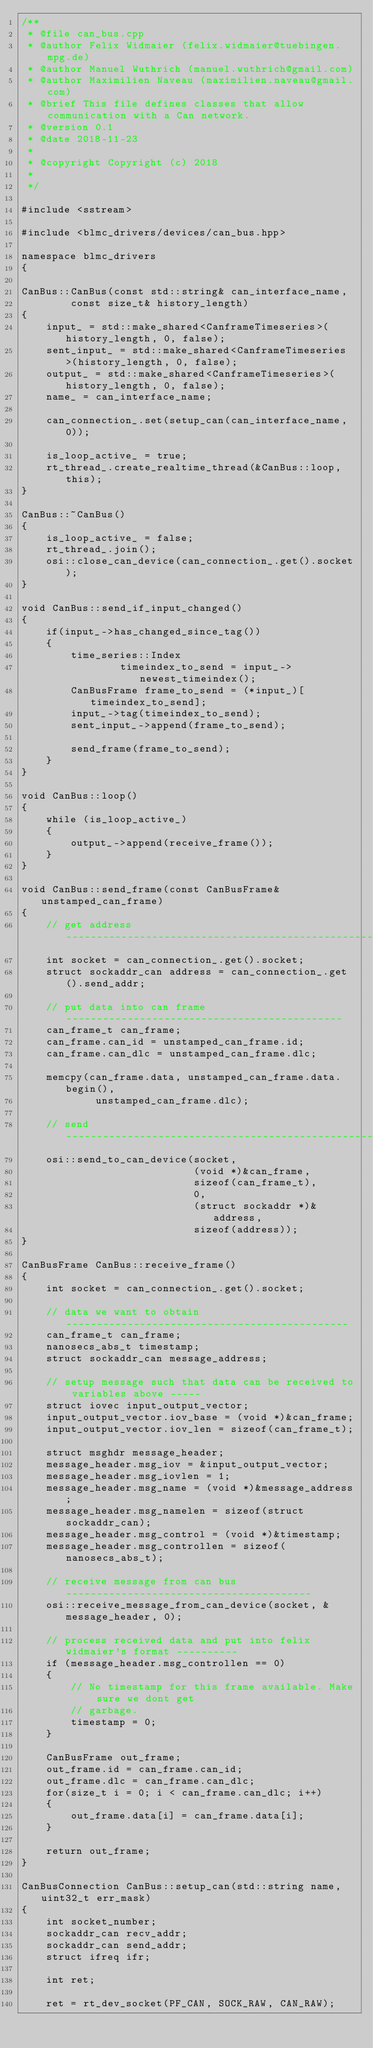<code> <loc_0><loc_0><loc_500><loc_500><_C++_>/**
 * @file can_bus.cpp
 * @author Felix Widmaier (felix.widmaier@tuebingen.mpg.de)
 * @author Manuel Wuthrich (manuel.wuthrich@gmail.com)
 * @author Maximilien Naveau (maximilien.naveau@gmail.com)
 * @brief This file defines classes that allow communication with a Can network.
 * @version 0.1
 * @date 2018-11-23
 *
 * @copyright Copyright (c) 2018
 *
 */

#include <sstream>

#include <blmc_drivers/devices/can_bus.hpp>

namespace blmc_drivers
{

CanBus::CanBus(const std::string& can_interface_name,
        const size_t& history_length)
{
    input_ = std::make_shared<CanframeTimeseries>(history_length, 0, false);
    sent_input_ = std::make_shared<CanframeTimeseries>(history_length, 0, false);
    output_ = std::make_shared<CanframeTimeseries>(history_length, 0, false);
    name_ = can_interface_name;

    can_connection_.set(setup_can(can_interface_name, 0));

    is_loop_active_ = true;
    rt_thread_.create_realtime_thread(&CanBus::loop, this);
}

CanBus::~CanBus()
{
    is_loop_active_ = false;
    rt_thread_.join();
    osi::close_can_device(can_connection_.get().socket);
}

void CanBus::send_if_input_changed()
{
    if(input_->has_changed_since_tag())
    {
        time_series::Index
                timeindex_to_send = input_->newest_timeindex();
        CanBusFrame frame_to_send = (*input_)[timeindex_to_send];
        input_->tag(timeindex_to_send);
        sent_input_->append(frame_to_send);

        send_frame(frame_to_send);
    }
}

void CanBus::loop()
{
    while (is_loop_active_)
    {
        output_->append(receive_frame());
    }
}

void CanBus::send_frame(const CanBusFrame& unstamped_can_frame)
{
    // get address ---------------------------------------------------------
    int socket = can_connection_.get().socket;
    struct sockaddr_can address = can_connection_.get().send_addr;

    // put data into can frame ---------------------------------------------
    can_frame_t can_frame;
    can_frame.can_id = unstamped_can_frame.id;
    can_frame.can_dlc = unstamped_can_frame.dlc;

    memcpy(can_frame.data, unstamped_can_frame.data.begin(),
            unstamped_can_frame.dlc);

    // send ----------------------------------------------------------------
    osi::send_to_can_device(socket,
                            (void *)&can_frame,
                            sizeof(can_frame_t),
                            0,
                            (struct sockaddr *)&address,
                            sizeof(address));
}

CanBusFrame CanBus::receive_frame()
{
    int socket = can_connection_.get().socket;

    // data we want to obtain ----------------------------------------------
    can_frame_t can_frame;
    nanosecs_abs_t timestamp;
    struct sockaddr_can message_address;

    // setup message such that data can be received to variables above -----
    struct iovec input_output_vector;
    input_output_vector.iov_base = (void *)&can_frame;
    input_output_vector.iov_len = sizeof(can_frame_t);

    struct msghdr message_header;
    message_header.msg_iov = &input_output_vector;
    message_header.msg_iovlen = 1;
    message_header.msg_name = (void *)&message_address;
    message_header.msg_namelen = sizeof(struct sockaddr_can);
    message_header.msg_control = (void *)&timestamp;
    message_header.msg_controllen = sizeof(nanosecs_abs_t);

    // receive message from can bus ----------------------------------------
    osi::receive_message_from_can_device(socket, &message_header, 0);

    // process received data and put into felix widmaier's format ----------
    if (message_header.msg_controllen == 0)
    {
        // No timestamp for this frame available. Make sure we dont get
        // garbage.
        timestamp = 0;
    }

    CanBusFrame out_frame;
    out_frame.id = can_frame.can_id;
    out_frame.dlc = can_frame.can_dlc;
    for(size_t i = 0; i < can_frame.can_dlc; i++)
    {
        out_frame.data[i] = can_frame.data[i];
    }

    return out_frame;
}

CanBusConnection CanBus::setup_can(std::string name, uint32_t err_mask)
{
    int socket_number;
    sockaddr_can recv_addr;
    sockaddr_can send_addr;
    struct ifreq ifr;

    int ret;

    ret = rt_dev_socket(PF_CAN, SOCK_RAW, CAN_RAW);</code> 